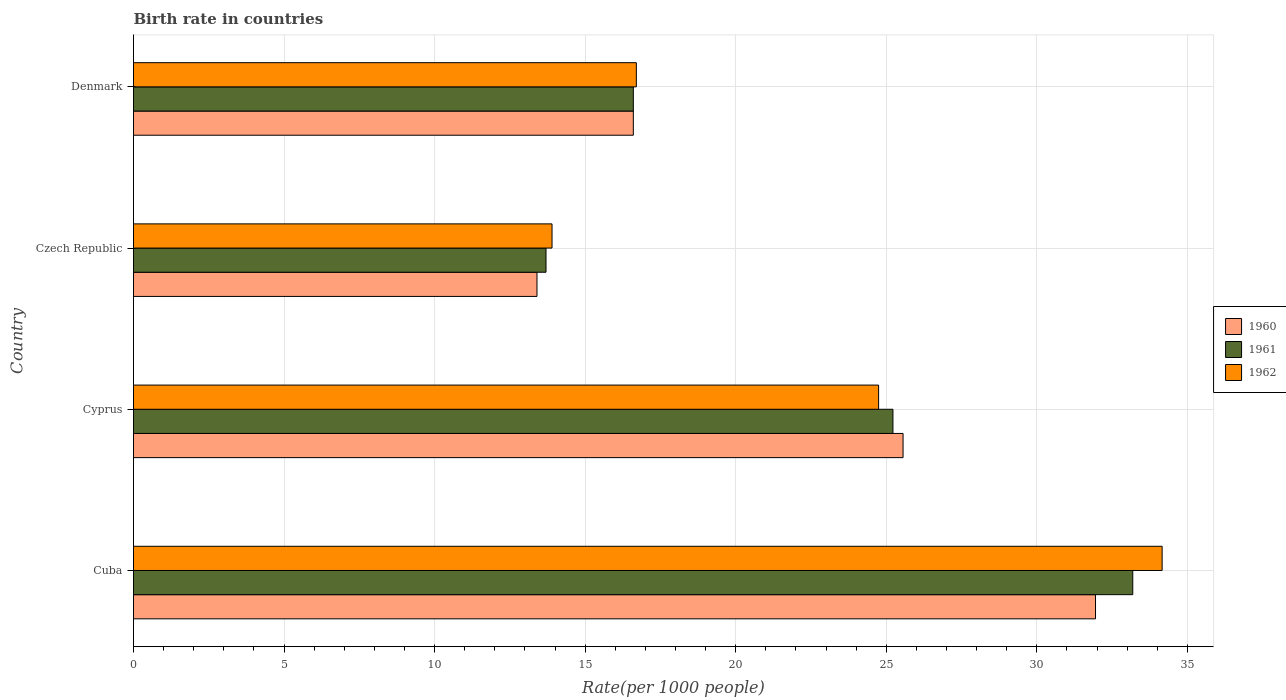How many different coloured bars are there?
Your response must be concise. 3. Are the number of bars per tick equal to the number of legend labels?
Keep it short and to the point. Yes. Are the number of bars on each tick of the Y-axis equal?
Provide a succinct answer. Yes. What is the label of the 4th group of bars from the top?
Keep it short and to the point. Cuba. What is the birth rate in 1960 in Cyprus?
Your answer should be very brief. 25.56. Across all countries, what is the maximum birth rate in 1960?
Your answer should be compact. 31.95. Across all countries, what is the minimum birth rate in 1962?
Provide a succinct answer. 13.9. In which country was the birth rate in 1960 maximum?
Ensure brevity in your answer.  Cuba. In which country was the birth rate in 1962 minimum?
Give a very brief answer. Czech Republic. What is the total birth rate in 1960 in the graph?
Your answer should be compact. 87.51. What is the difference between the birth rate in 1961 in Cuba and that in Cyprus?
Give a very brief answer. 7.96. What is the difference between the birth rate in 1962 in Czech Republic and the birth rate in 1961 in Cyprus?
Offer a very short reply. -11.32. What is the average birth rate in 1962 per country?
Ensure brevity in your answer.  22.38. What is the difference between the birth rate in 1960 and birth rate in 1962 in Czech Republic?
Provide a succinct answer. -0.5. What is the ratio of the birth rate in 1961 in Cyprus to that in Denmark?
Keep it short and to the point. 1.52. Is the birth rate in 1961 in Cyprus less than that in Denmark?
Give a very brief answer. No. What is the difference between the highest and the second highest birth rate in 1960?
Your answer should be very brief. 6.39. What is the difference between the highest and the lowest birth rate in 1961?
Provide a succinct answer. 19.49. What does the 3rd bar from the top in Czech Republic represents?
Keep it short and to the point. 1960. Is it the case that in every country, the sum of the birth rate in 1962 and birth rate in 1960 is greater than the birth rate in 1961?
Offer a very short reply. Yes. Are all the bars in the graph horizontal?
Ensure brevity in your answer.  Yes. How many countries are there in the graph?
Offer a very short reply. 4. What is the difference between two consecutive major ticks on the X-axis?
Your answer should be very brief. 5. Are the values on the major ticks of X-axis written in scientific E-notation?
Ensure brevity in your answer.  No. Does the graph contain grids?
Provide a short and direct response. Yes. Where does the legend appear in the graph?
Your response must be concise. Center right. How are the legend labels stacked?
Your answer should be compact. Vertical. What is the title of the graph?
Give a very brief answer. Birth rate in countries. Does "1977" appear as one of the legend labels in the graph?
Keep it short and to the point. No. What is the label or title of the X-axis?
Keep it short and to the point. Rate(per 1000 people). What is the Rate(per 1000 people) of 1960 in Cuba?
Your answer should be compact. 31.95. What is the Rate(per 1000 people) of 1961 in Cuba?
Keep it short and to the point. 33.19. What is the Rate(per 1000 people) in 1962 in Cuba?
Offer a very short reply. 34.16. What is the Rate(per 1000 people) of 1960 in Cyprus?
Your answer should be very brief. 25.56. What is the Rate(per 1000 people) in 1961 in Cyprus?
Your answer should be compact. 25.22. What is the Rate(per 1000 people) in 1962 in Cyprus?
Give a very brief answer. 24.75. What is the Rate(per 1000 people) of 1962 in Czech Republic?
Ensure brevity in your answer.  13.9. What is the Rate(per 1000 people) in 1960 in Denmark?
Offer a terse response. 16.6. What is the Rate(per 1000 people) of 1962 in Denmark?
Provide a succinct answer. 16.7. Across all countries, what is the maximum Rate(per 1000 people) of 1960?
Ensure brevity in your answer.  31.95. Across all countries, what is the maximum Rate(per 1000 people) of 1961?
Your answer should be very brief. 33.19. Across all countries, what is the maximum Rate(per 1000 people) in 1962?
Make the answer very short. 34.16. Across all countries, what is the minimum Rate(per 1000 people) of 1962?
Give a very brief answer. 13.9. What is the total Rate(per 1000 people) of 1960 in the graph?
Give a very brief answer. 87.51. What is the total Rate(per 1000 people) of 1961 in the graph?
Offer a terse response. 88.71. What is the total Rate(per 1000 people) of 1962 in the graph?
Give a very brief answer. 89.51. What is the difference between the Rate(per 1000 people) in 1960 in Cuba and that in Cyprus?
Provide a short and direct response. 6.39. What is the difference between the Rate(per 1000 people) of 1961 in Cuba and that in Cyprus?
Ensure brevity in your answer.  7.96. What is the difference between the Rate(per 1000 people) of 1962 in Cuba and that in Cyprus?
Offer a very short reply. 9.42. What is the difference between the Rate(per 1000 people) of 1960 in Cuba and that in Czech Republic?
Keep it short and to the point. 18.55. What is the difference between the Rate(per 1000 people) of 1961 in Cuba and that in Czech Republic?
Offer a terse response. 19.49. What is the difference between the Rate(per 1000 people) in 1962 in Cuba and that in Czech Republic?
Offer a very short reply. 20.26. What is the difference between the Rate(per 1000 people) in 1960 in Cuba and that in Denmark?
Your answer should be compact. 15.35. What is the difference between the Rate(per 1000 people) of 1961 in Cuba and that in Denmark?
Make the answer very short. 16.59. What is the difference between the Rate(per 1000 people) in 1962 in Cuba and that in Denmark?
Your answer should be very brief. 17.46. What is the difference between the Rate(per 1000 people) in 1960 in Cyprus and that in Czech Republic?
Offer a very short reply. 12.16. What is the difference between the Rate(per 1000 people) of 1961 in Cyprus and that in Czech Republic?
Make the answer very short. 11.52. What is the difference between the Rate(per 1000 people) in 1962 in Cyprus and that in Czech Republic?
Keep it short and to the point. 10.85. What is the difference between the Rate(per 1000 people) in 1960 in Cyprus and that in Denmark?
Your response must be concise. 8.96. What is the difference between the Rate(per 1000 people) of 1961 in Cyprus and that in Denmark?
Keep it short and to the point. 8.62. What is the difference between the Rate(per 1000 people) in 1962 in Cyprus and that in Denmark?
Offer a terse response. 8.05. What is the difference between the Rate(per 1000 people) of 1960 in Czech Republic and that in Denmark?
Provide a short and direct response. -3.2. What is the difference between the Rate(per 1000 people) in 1962 in Czech Republic and that in Denmark?
Your answer should be very brief. -2.8. What is the difference between the Rate(per 1000 people) of 1960 in Cuba and the Rate(per 1000 people) of 1961 in Cyprus?
Make the answer very short. 6.73. What is the difference between the Rate(per 1000 people) in 1960 in Cuba and the Rate(per 1000 people) in 1962 in Cyprus?
Your answer should be very brief. 7.2. What is the difference between the Rate(per 1000 people) in 1961 in Cuba and the Rate(per 1000 people) in 1962 in Cyprus?
Give a very brief answer. 8.44. What is the difference between the Rate(per 1000 people) in 1960 in Cuba and the Rate(per 1000 people) in 1961 in Czech Republic?
Your response must be concise. 18.25. What is the difference between the Rate(per 1000 people) of 1960 in Cuba and the Rate(per 1000 people) of 1962 in Czech Republic?
Provide a short and direct response. 18.05. What is the difference between the Rate(per 1000 people) of 1961 in Cuba and the Rate(per 1000 people) of 1962 in Czech Republic?
Your answer should be compact. 19.29. What is the difference between the Rate(per 1000 people) in 1960 in Cuba and the Rate(per 1000 people) in 1961 in Denmark?
Provide a short and direct response. 15.35. What is the difference between the Rate(per 1000 people) of 1960 in Cuba and the Rate(per 1000 people) of 1962 in Denmark?
Make the answer very short. 15.25. What is the difference between the Rate(per 1000 people) in 1961 in Cuba and the Rate(per 1000 people) in 1962 in Denmark?
Ensure brevity in your answer.  16.49. What is the difference between the Rate(per 1000 people) in 1960 in Cyprus and the Rate(per 1000 people) in 1961 in Czech Republic?
Ensure brevity in your answer.  11.86. What is the difference between the Rate(per 1000 people) of 1960 in Cyprus and the Rate(per 1000 people) of 1962 in Czech Republic?
Give a very brief answer. 11.66. What is the difference between the Rate(per 1000 people) of 1961 in Cyprus and the Rate(per 1000 people) of 1962 in Czech Republic?
Your answer should be compact. 11.32. What is the difference between the Rate(per 1000 people) of 1960 in Cyprus and the Rate(per 1000 people) of 1961 in Denmark?
Offer a very short reply. 8.96. What is the difference between the Rate(per 1000 people) in 1960 in Cyprus and the Rate(per 1000 people) in 1962 in Denmark?
Ensure brevity in your answer.  8.86. What is the difference between the Rate(per 1000 people) in 1961 in Cyprus and the Rate(per 1000 people) in 1962 in Denmark?
Your answer should be compact. 8.52. What is the difference between the Rate(per 1000 people) of 1960 in Czech Republic and the Rate(per 1000 people) of 1961 in Denmark?
Make the answer very short. -3.2. What is the difference between the Rate(per 1000 people) in 1960 in Czech Republic and the Rate(per 1000 people) in 1962 in Denmark?
Provide a succinct answer. -3.3. What is the average Rate(per 1000 people) in 1960 per country?
Ensure brevity in your answer.  21.88. What is the average Rate(per 1000 people) in 1961 per country?
Offer a terse response. 22.18. What is the average Rate(per 1000 people) in 1962 per country?
Keep it short and to the point. 22.38. What is the difference between the Rate(per 1000 people) in 1960 and Rate(per 1000 people) in 1961 in Cuba?
Offer a terse response. -1.24. What is the difference between the Rate(per 1000 people) in 1960 and Rate(per 1000 people) in 1962 in Cuba?
Your answer should be very brief. -2.21. What is the difference between the Rate(per 1000 people) of 1961 and Rate(per 1000 people) of 1962 in Cuba?
Your response must be concise. -0.97. What is the difference between the Rate(per 1000 people) of 1960 and Rate(per 1000 people) of 1961 in Cyprus?
Make the answer very short. 0.34. What is the difference between the Rate(per 1000 people) of 1960 and Rate(per 1000 people) of 1962 in Cyprus?
Keep it short and to the point. 0.81. What is the difference between the Rate(per 1000 people) of 1961 and Rate(per 1000 people) of 1962 in Cyprus?
Keep it short and to the point. 0.48. What is the difference between the Rate(per 1000 people) in 1960 and Rate(per 1000 people) in 1961 in Denmark?
Offer a very short reply. 0. What is the difference between the Rate(per 1000 people) of 1961 and Rate(per 1000 people) of 1962 in Denmark?
Your response must be concise. -0.1. What is the ratio of the Rate(per 1000 people) of 1960 in Cuba to that in Cyprus?
Ensure brevity in your answer.  1.25. What is the ratio of the Rate(per 1000 people) of 1961 in Cuba to that in Cyprus?
Offer a very short reply. 1.32. What is the ratio of the Rate(per 1000 people) in 1962 in Cuba to that in Cyprus?
Your response must be concise. 1.38. What is the ratio of the Rate(per 1000 people) in 1960 in Cuba to that in Czech Republic?
Provide a short and direct response. 2.38. What is the ratio of the Rate(per 1000 people) in 1961 in Cuba to that in Czech Republic?
Keep it short and to the point. 2.42. What is the ratio of the Rate(per 1000 people) of 1962 in Cuba to that in Czech Republic?
Your answer should be very brief. 2.46. What is the ratio of the Rate(per 1000 people) in 1960 in Cuba to that in Denmark?
Provide a succinct answer. 1.92. What is the ratio of the Rate(per 1000 people) of 1961 in Cuba to that in Denmark?
Your response must be concise. 2. What is the ratio of the Rate(per 1000 people) of 1962 in Cuba to that in Denmark?
Provide a short and direct response. 2.05. What is the ratio of the Rate(per 1000 people) of 1960 in Cyprus to that in Czech Republic?
Offer a very short reply. 1.91. What is the ratio of the Rate(per 1000 people) of 1961 in Cyprus to that in Czech Republic?
Your answer should be very brief. 1.84. What is the ratio of the Rate(per 1000 people) in 1962 in Cyprus to that in Czech Republic?
Provide a succinct answer. 1.78. What is the ratio of the Rate(per 1000 people) of 1960 in Cyprus to that in Denmark?
Offer a very short reply. 1.54. What is the ratio of the Rate(per 1000 people) in 1961 in Cyprus to that in Denmark?
Provide a short and direct response. 1.52. What is the ratio of the Rate(per 1000 people) of 1962 in Cyprus to that in Denmark?
Your answer should be compact. 1.48. What is the ratio of the Rate(per 1000 people) of 1960 in Czech Republic to that in Denmark?
Offer a very short reply. 0.81. What is the ratio of the Rate(per 1000 people) in 1961 in Czech Republic to that in Denmark?
Provide a succinct answer. 0.83. What is the ratio of the Rate(per 1000 people) in 1962 in Czech Republic to that in Denmark?
Your answer should be compact. 0.83. What is the difference between the highest and the second highest Rate(per 1000 people) in 1960?
Offer a terse response. 6.39. What is the difference between the highest and the second highest Rate(per 1000 people) of 1961?
Keep it short and to the point. 7.96. What is the difference between the highest and the second highest Rate(per 1000 people) of 1962?
Give a very brief answer. 9.42. What is the difference between the highest and the lowest Rate(per 1000 people) in 1960?
Offer a very short reply. 18.55. What is the difference between the highest and the lowest Rate(per 1000 people) in 1961?
Provide a short and direct response. 19.49. What is the difference between the highest and the lowest Rate(per 1000 people) in 1962?
Ensure brevity in your answer.  20.26. 